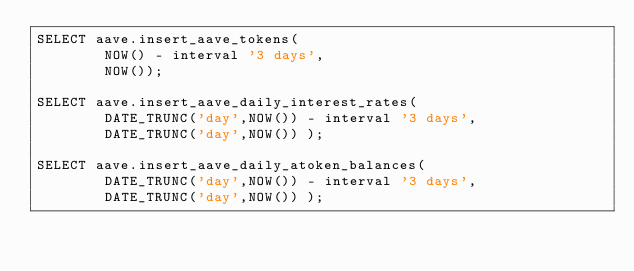<code> <loc_0><loc_0><loc_500><loc_500><_SQL_>SELECT aave.insert_aave_tokens(
        NOW() - interval '3 days',
        NOW());

SELECT aave.insert_aave_daily_interest_rates(
        DATE_TRUNC('day',NOW()) - interval '3 days',
        DATE_TRUNC('day',NOW()) );

SELECT aave.insert_aave_daily_atoken_balances(
        DATE_TRUNC('day',NOW()) - interval '3 days',
        DATE_TRUNC('day',NOW()) );
</code> 